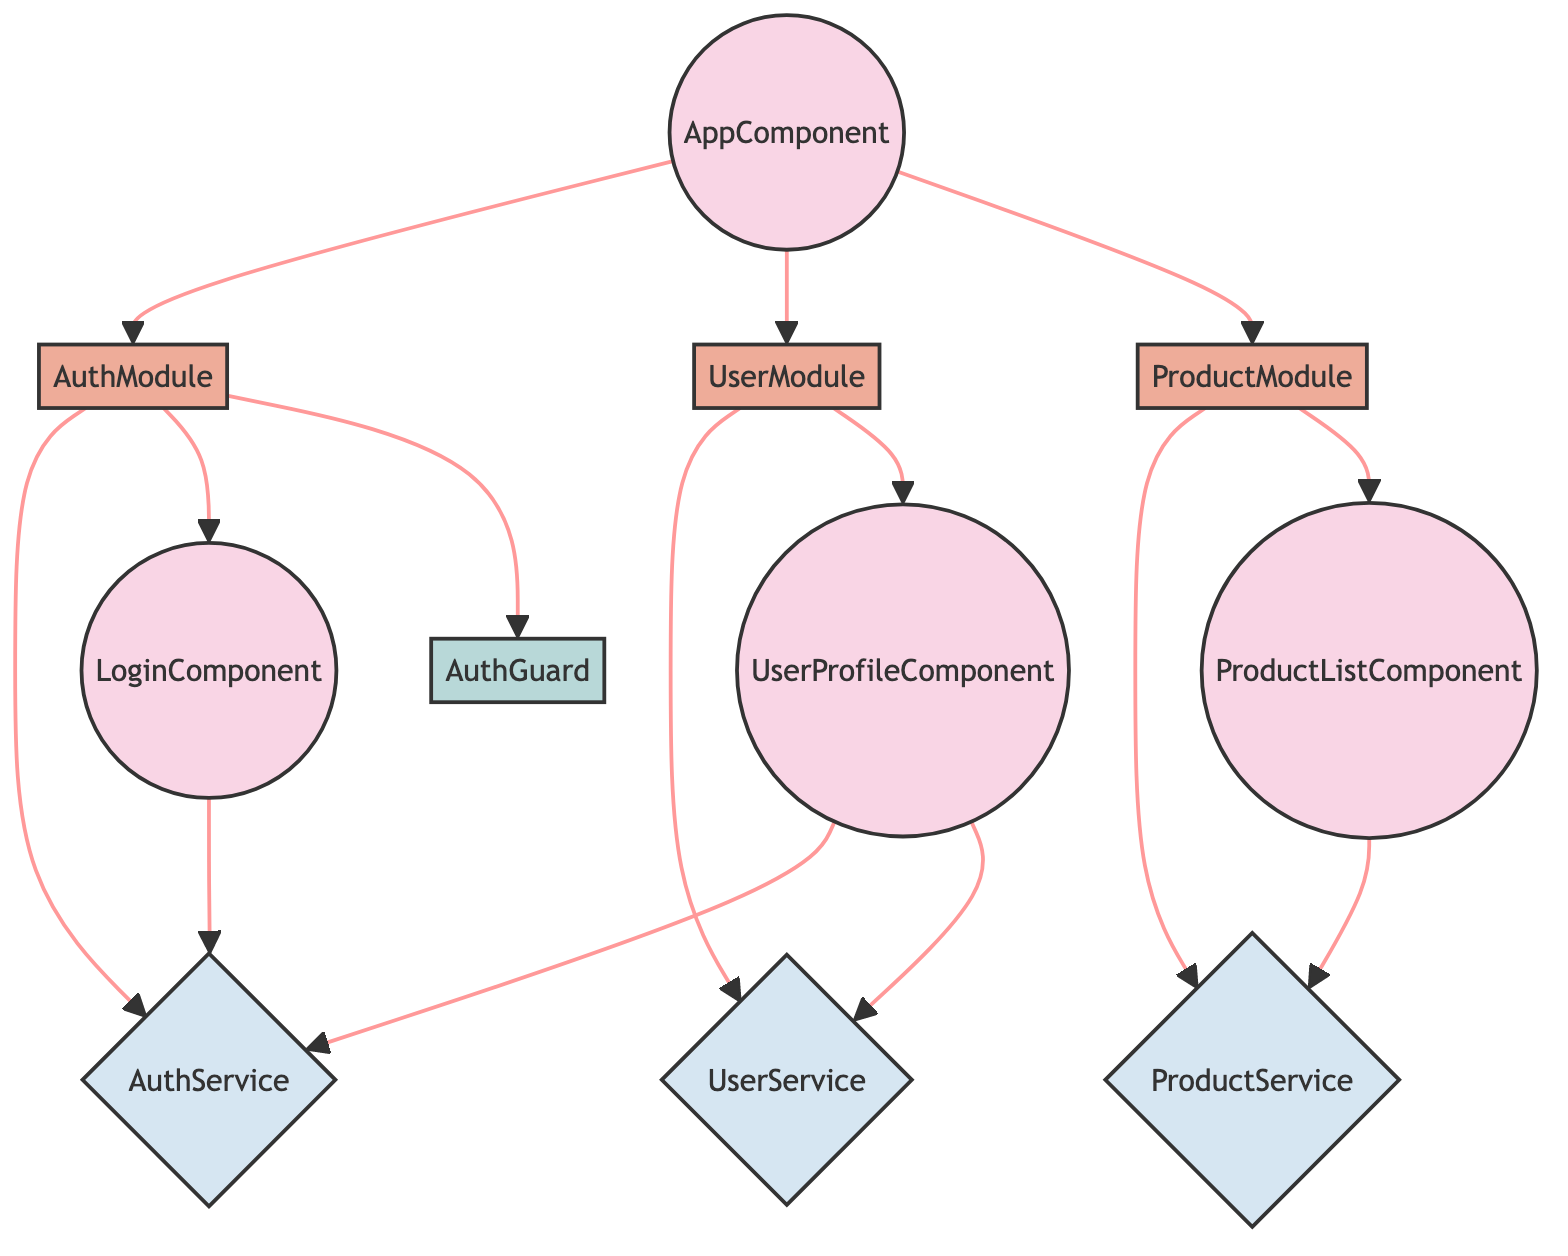What is the total number of nodes in the diagram? The nodes represent components, modules, services, and guards. Counting all the nodes listed, there are ten distinct nodes: AppComponent, AuthModule, UserModule, ProductModule, AuthService, UserService, ProductService, AuthGuard, LoginComponent, and UserProfileComponent.
Answer: 10 How many services are represented in the diagram? Reviewing the node list, we identify the services as AuthService, UserService, and ProductService. Thus, there are three service nodes in total.
Answer: 3 Which module is connected to the AuthService? The edges indicate that the AuthModule is directly connected to the AuthService, meaning it depends on it for its functionality.
Answer: AuthModule What component does the UserModule connect to? The UserModule is linked to the UserProfileComponent according to the edges in the diagram. This means UserProfileComponent depends on the UserModule.
Answer: UserProfileComponent How many edges are there in the diagram? Counting the connections (edges) listed in the data, there are a total of twelve edges, which indicate the dependencies between the modules, services, and components.
Answer: 12 What is the relationship between AppComponent and ProductModule? The diagram shows a direct connection (edge) from AppComponent to ProductModule, indicating that AppComponent is dependent on ProductModule for functionality.
Answer: dependent Which component is a child of AuthModule? According to the edges, the LoginComponent is child to the AuthModule. It indicates that LoginComponent relies on the AuthModule.
Answer: LoginComponent Identify a component that directly utilizes ProductService. The ProductListComponent directly utilizes ProductService, based on the edge that connects them in the diagram.
Answer: ProductListComponent What type of component is UserProfileComponent categorized as? The node classification specifies that UserProfileComponent is a component type, which is highlighted in the diagram.
Answer: component Which guard is connected to AuthModule? The AuthGuard is directly connected to the AuthModule, which signifies that it is a part of the authentication process managed by this module.
Answer: AuthGuard 